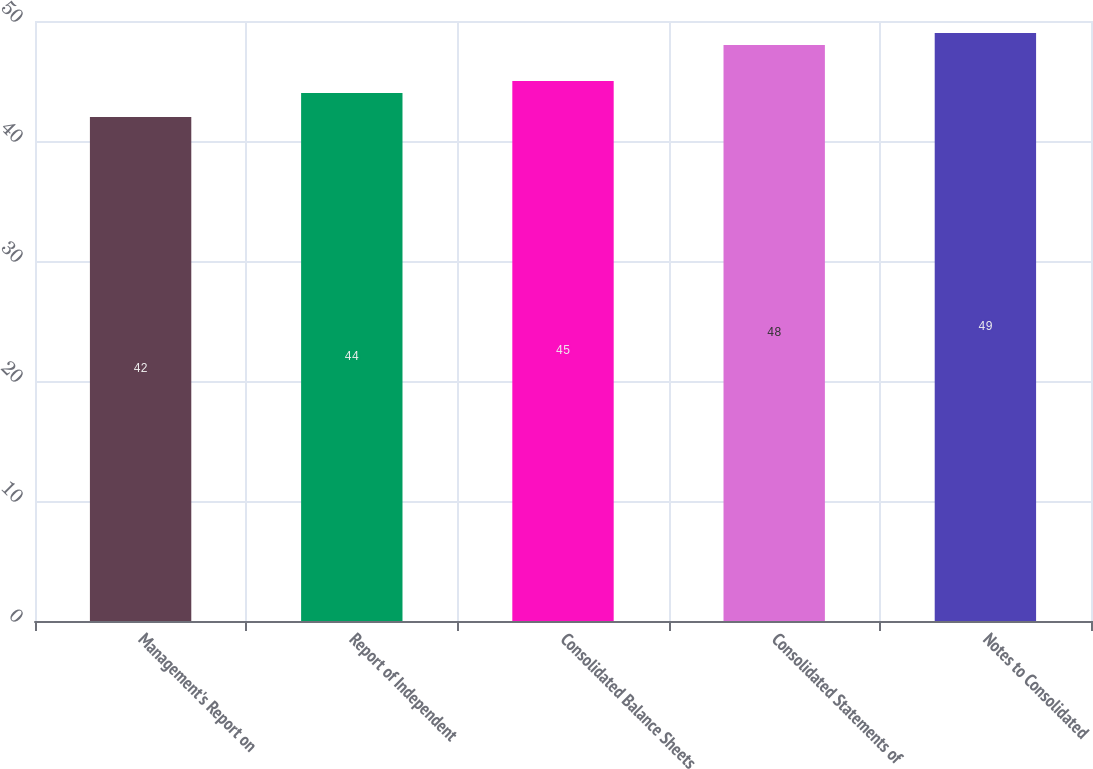Convert chart. <chart><loc_0><loc_0><loc_500><loc_500><bar_chart><fcel>Management's Report on<fcel>Report of Independent<fcel>Consolidated Balance Sheets<fcel>Consolidated Statements of<fcel>Notes to Consolidated<nl><fcel>42<fcel>44<fcel>45<fcel>48<fcel>49<nl></chart> 